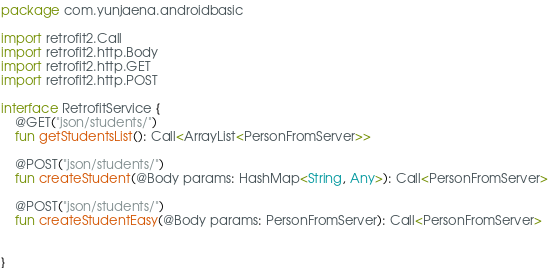Convert code to text. <code><loc_0><loc_0><loc_500><loc_500><_Kotlin_>package com.yunjaena.androidbasic

import retrofit2.Call
import retrofit2.http.Body
import retrofit2.http.GET
import retrofit2.http.POST

interface RetrofitService {
    @GET("json/students/")
    fun getStudentsList(): Call<ArrayList<PersonFromServer>>

    @POST("json/students/")
    fun createStudent(@Body params: HashMap<String, Any>): Call<PersonFromServer>

    @POST("json/students/")
    fun createStudentEasy(@Body params: PersonFromServer): Call<PersonFromServer>


}</code> 